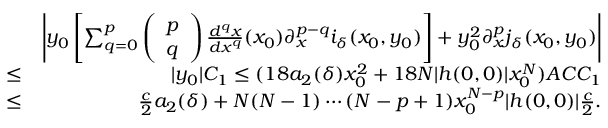Convert formula to latex. <formula><loc_0><loc_0><loc_500><loc_500>\begin{array} { r l r } & { \left | y _ { 0 } \left [ \sum _ { q = 0 } ^ { p } \left ( \begin{array} { l } { p } \\ { q } \end{array} \right ) \frac { d ^ { q } x } { d x ^ { q } } ( x _ { 0 } ) \partial _ { x } ^ { p - q } i _ { \delta } ( x _ { 0 } , y _ { 0 } ) \right ] + y _ { 0 } ^ { 2 } \partial _ { x } ^ { p } j _ { \delta } ( x _ { 0 } , y _ { 0 } ) \right | } \\ & { \leq } & { | y _ { 0 } | C _ { 1 } \leq ( 1 8 a _ { 2 } ( \delta ) x _ { 0 } ^ { 2 } + 1 8 N | h ( 0 , 0 ) | x _ { 0 } ^ { N } ) A C C _ { 1 } } \\ & { \leq } & { \frac { c } { 2 } a _ { 2 } ( \delta ) + N ( N - 1 ) \cdots ( N - p + 1 ) x _ { 0 } ^ { N - p } | h ( 0 , 0 ) | \frac { c } { 2 } . } \end{array}</formula> 